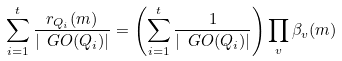Convert formula to latex. <formula><loc_0><loc_0><loc_500><loc_500>\sum _ { i = 1 } ^ { t } \frac { r _ { Q _ { i } } ( m ) } { | \ G O ( Q _ { i } ) | } = \left ( \sum _ { i = 1 } ^ { t } \frac { 1 } { | \ G O ( Q _ { i } ) | } \right ) \prod _ { v } \beta _ { v } ( m )</formula> 